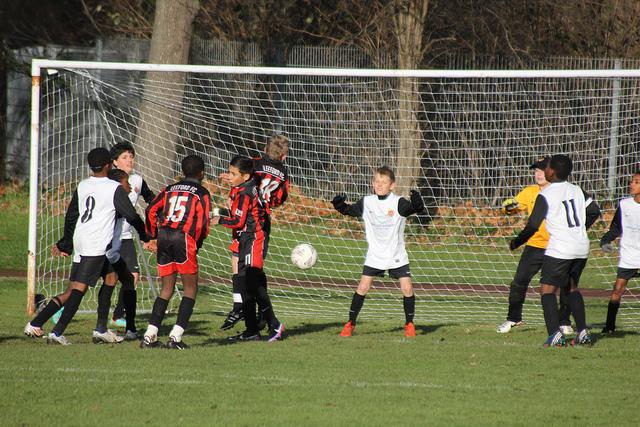What sport are they playing?
Concise answer only. Soccer. Color is the goaltenders shirt?
Concise answer only. White. Where is number 8?
Quick response, please. Left. How many kids are wearing black and white?
Concise answer only. 5. Is the boy in the middle being attacked?
Write a very short answer. No. Does the boy have his head stuck in the net?
Be succinct. No. 